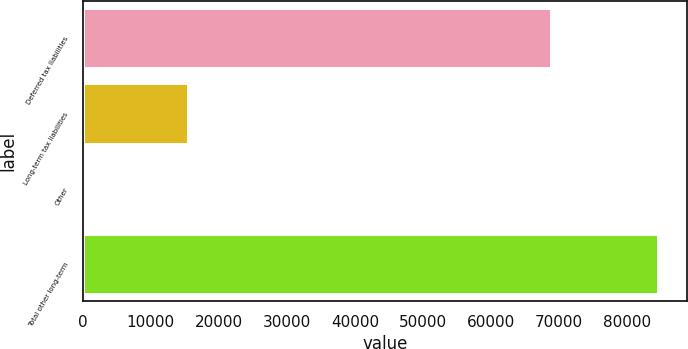Convert chart to OTSL. <chart><loc_0><loc_0><loc_500><loc_500><bar_chart><fcel>Deferred tax liabilities<fcel>Long-term tax liabilities<fcel>Other<fcel>Total other long-term<nl><fcel>68833<fcel>15549<fcel>161<fcel>84543<nl></chart> 